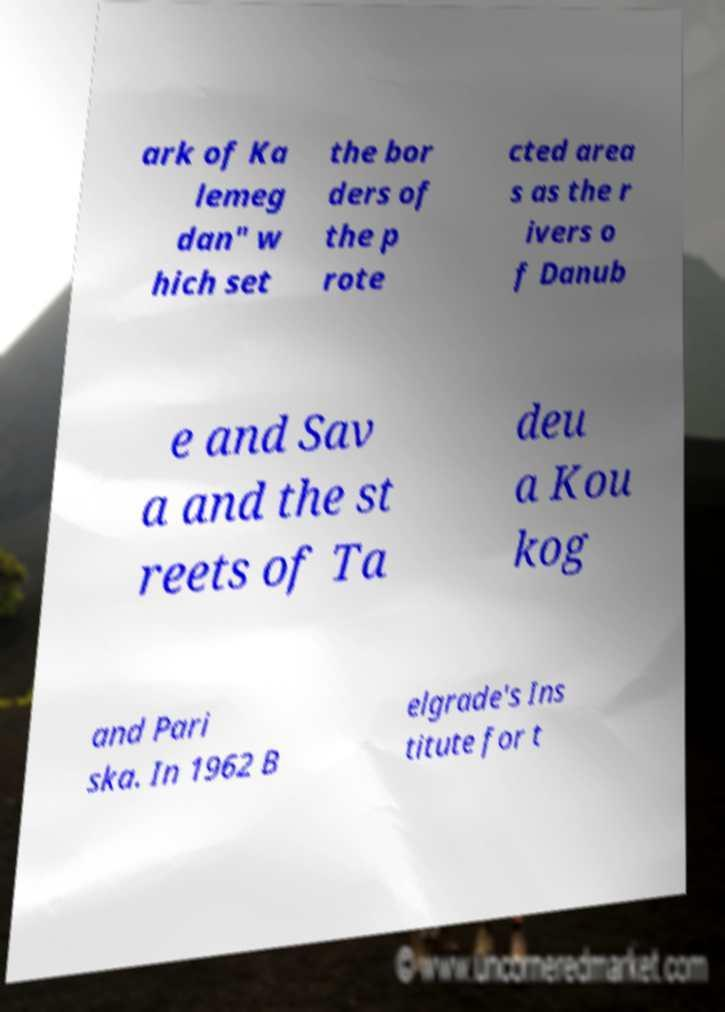I need the written content from this picture converted into text. Can you do that? ark of Ka lemeg dan" w hich set the bor ders of the p rote cted area s as the r ivers o f Danub e and Sav a and the st reets of Ta deu a Kou kog and Pari ska. In 1962 B elgrade's Ins titute for t 